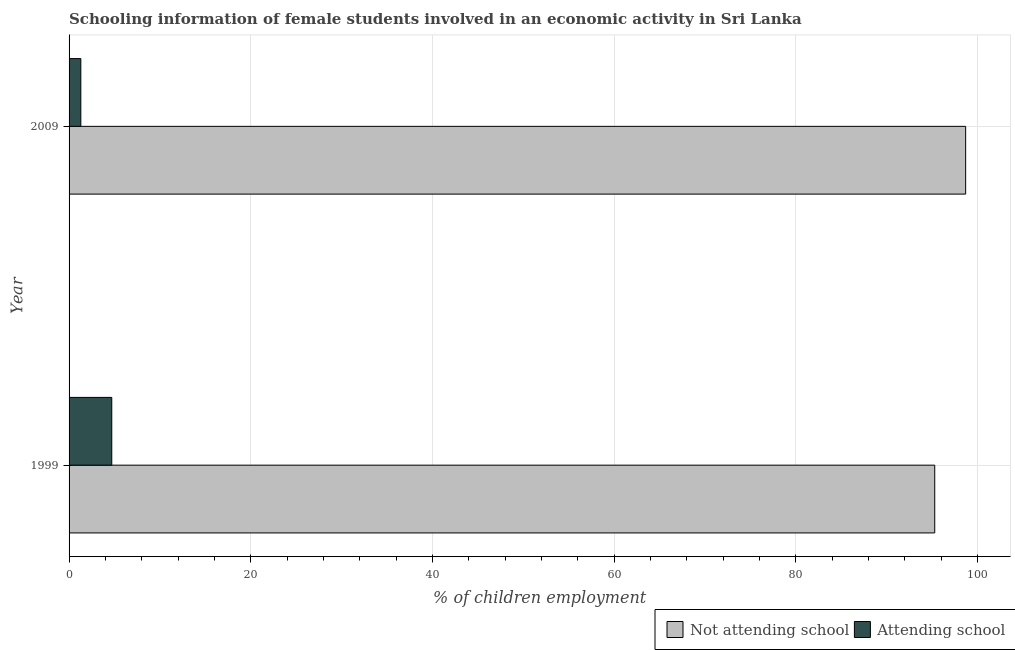How many groups of bars are there?
Provide a succinct answer. 2. Are the number of bars per tick equal to the number of legend labels?
Provide a short and direct response. Yes. Are the number of bars on each tick of the Y-axis equal?
Give a very brief answer. Yes. Across all years, what is the maximum percentage of employed females who are not attending school?
Your answer should be very brief. 98.71. Across all years, what is the minimum percentage of employed females who are not attending school?
Provide a succinct answer. 95.3. In which year was the percentage of employed females who are attending school maximum?
Your answer should be compact. 1999. What is the total percentage of employed females who are not attending school in the graph?
Give a very brief answer. 194.01. What is the difference between the percentage of employed females who are not attending school in 1999 and that in 2009?
Provide a succinct answer. -3.4. What is the difference between the percentage of employed females who are not attending school in 2009 and the percentage of employed females who are attending school in 1999?
Give a very brief answer. 94.01. What is the average percentage of employed females who are not attending school per year?
Your response must be concise. 97. In the year 2009, what is the difference between the percentage of employed females who are attending school and percentage of employed females who are not attending school?
Your answer should be very brief. -97.41. What is the ratio of the percentage of employed females who are attending school in 1999 to that in 2009?
Give a very brief answer. 3.63. In how many years, is the percentage of employed females who are attending school greater than the average percentage of employed females who are attending school taken over all years?
Keep it short and to the point. 1. What does the 1st bar from the top in 2009 represents?
Offer a terse response. Attending school. What does the 1st bar from the bottom in 1999 represents?
Your response must be concise. Not attending school. How many years are there in the graph?
Give a very brief answer. 2. Does the graph contain any zero values?
Your answer should be compact. No. Does the graph contain grids?
Your answer should be very brief. Yes. How are the legend labels stacked?
Ensure brevity in your answer.  Horizontal. What is the title of the graph?
Keep it short and to the point. Schooling information of female students involved in an economic activity in Sri Lanka. What is the label or title of the X-axis?
Ensure brevity in your answer.  % of children employment. What is the label or title of the Y-axis?
Make the answer very short. Year. What is the % of children employment in Not attending school in 1999?
Your answer should be very brief. 95.3. What is the % of children employment of Attending school in 1999?
Offer a terse response. 4.7. What is the % of children employment of Not attending school in 2009?
Provide a short and direct response. 98.71. What is the % of children employment in Attending school in 2009?
Make the answer very short. 1.29. Across all years, what is the maximum % of children employment of Not attending school?
Ensure brevity in your answer.  98.71. Across all years, what is the maximum % of children employment in Attending school?
Offer a terse response. 4.7. Across all years, what is the minimum % of children employment of Not attending school?
Offer a terse response. 95.3. Across all years, what is the minimum % of children employment of Attending school?
Give a very brief answer. 1.29. What is the total % of children employment of Not attending school in the graph?
Your answer should be very brief. 194. What is the total % of children employment in Attending school in the graph?
Ensure brevity in your answer.  6. What is the difference between the % of children employment in Not attending school in 1999 and that in 2009?
Provide a short and direct response. -3.4. What is the difference between the % of children employment in Attending school in 1999 and that in 2009?
Your answer should be very brief. 3.4. What is the difference between the % of children employment in Not attending school in 1999 and the % of children employment in Attending school in 2009?
Provide a short and direct response. 94. What is the average % of children employment in Not attending school per year?
Your answer should be compact. 97. What is the average % of children employment in Attending school per year?
Ensure brevity in your answer.  3. In the year 1999, what is the difference between the % of children employment of Not attending school and % of children employment of Attending school?
Offer a very short reply. 90.6. In the year 2009, what is the difference between the % of children employment of Not attending school and % of children employment of Attending school?
Offer a very short reply. 97.41. What is the ratio of the % of children employment in Not attending school in 1999 to that in 2009?
Your response must be concise. 0.97. What is the ratio of the % of children employment in Attending school in 1999 to that in 2009?
Provide a short and direct response. 3.63. What is the difference between the highest and the second highest % of children employment in Not attending school?
Ensure brevity in your answer.  3.4. What is the difference between the highest and the second highest % of children employment of Attending school?
Your answer should be very brief. 3.4. What is the difference between the highest and the lowest % of children employment of Not attending school?
Keep it short and to the point. 3.4. What is the difference between the highest and the lowest % of children employment in Attending school?
Keep it short and to the point. 3.4. 